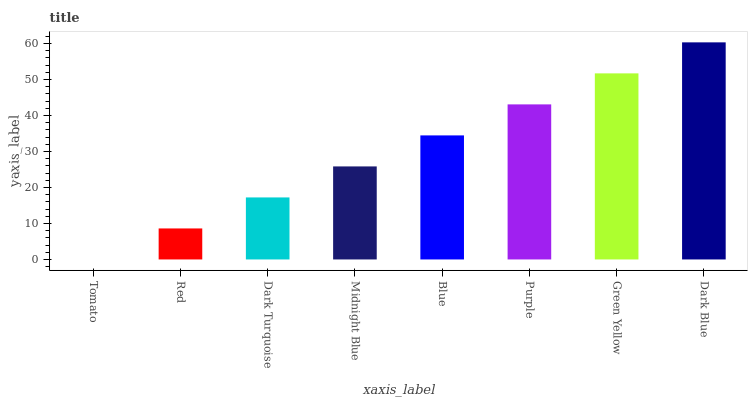Is Tomato the minimum?
Answer yes or no. Yes. Is Dark Blue the maximum?
Answer yes or no. Yes. Is Red the minimum?
Answer yes or no. No. Is Red the maximum?
Answer yes or no. No. Is Red greater than Tomato?
Answer yes or no. Yes. Is Tomato less than Red?
Answer yes or no. Yes. Is Tomato greater than Red?
Answer yes or no. No. Is Red less than Tomato?
Answer yes or no. No. Is Blue the high median?
Answer yes or no. Yes. Is Midnight Blue the low median?
Answer yes or no. Yes. Is Midnight Blue the high median?
Answer yes or no. No. Is Tomato the low median?
Answer yes or no. No. 